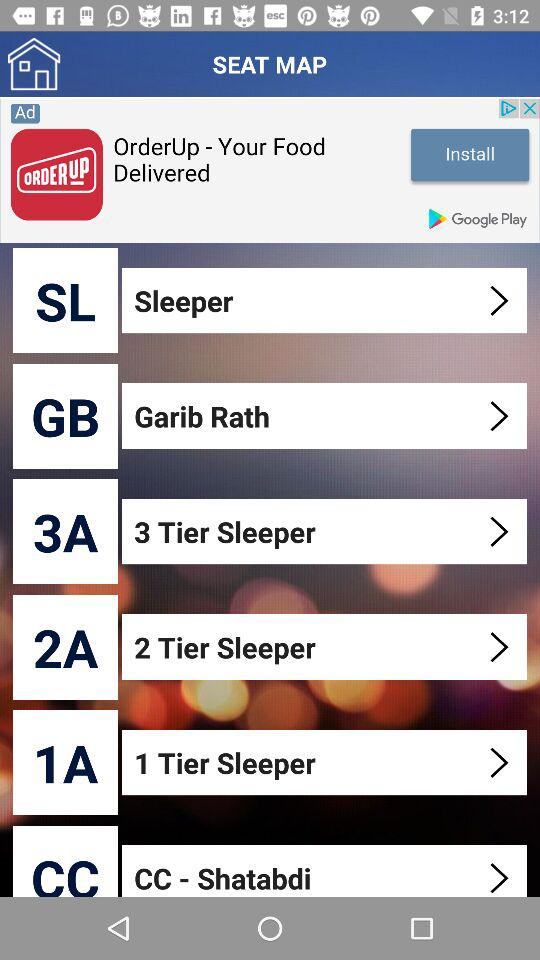What is the full form of 3A? The full form of 3A is "3 Tier Sleeper". 